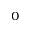Convert formula to latex. <formula><loc_0><loc_0><loc_500><loc_500>_ { 0 }</formula> 